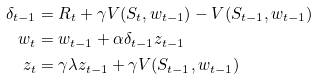<formula> <loc_0><loc_0><loc_500><loc_500>\delta _ { t - 1 } & = R _ { t } + \gamma V ( S _ { t } , w _ { t - 1 } ) - V ( S _ { t - 1 } , w _ { t - 1 } ) \\ w _ { t } & = w _ { t - 1 } + \alpha \delta _ { t - 1 } z _ { t - 1 } \\ z _ { t } & = \gamma \lambda z _ { t - 1 } + \gamma V ( S _ { t - 1 } , w _ { t - 1 } )</formula> 